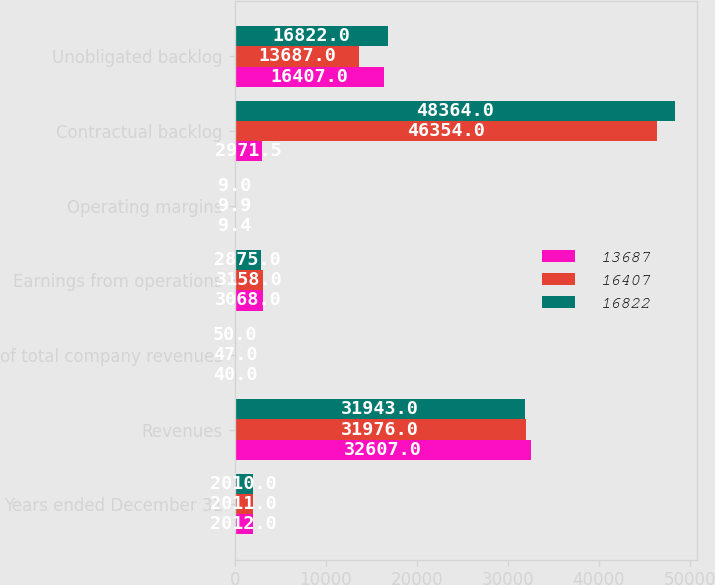<chart> <loc_0><loc_0><loc_500><loc_500><stacked_bar_chart><ecel><fcel>Years ended December 31<fcel>Revenues<fcel>of total company revenues<fcel>Earnings from operations<fcel>Operating margins<fcel>Contractual backlog<fcel>Unobligated backlog<nl><fcel>13687<fcel>2012<fcel>32607<fcel>40<fcel>3068<fcel>9.4<fcel>2971.5<fcel>16407<nl><fcel>16407<fcel>2011<fcel>31976<fcel>47<fcel>3158<fcel>9.9<fcel>46354<fcel>13687<nl><fcel>16822<fcel>2010<fcel>31943<fcel>50<fcel>2875<fcel>9<fcel>48364<fcel>16822<nl></chart> 